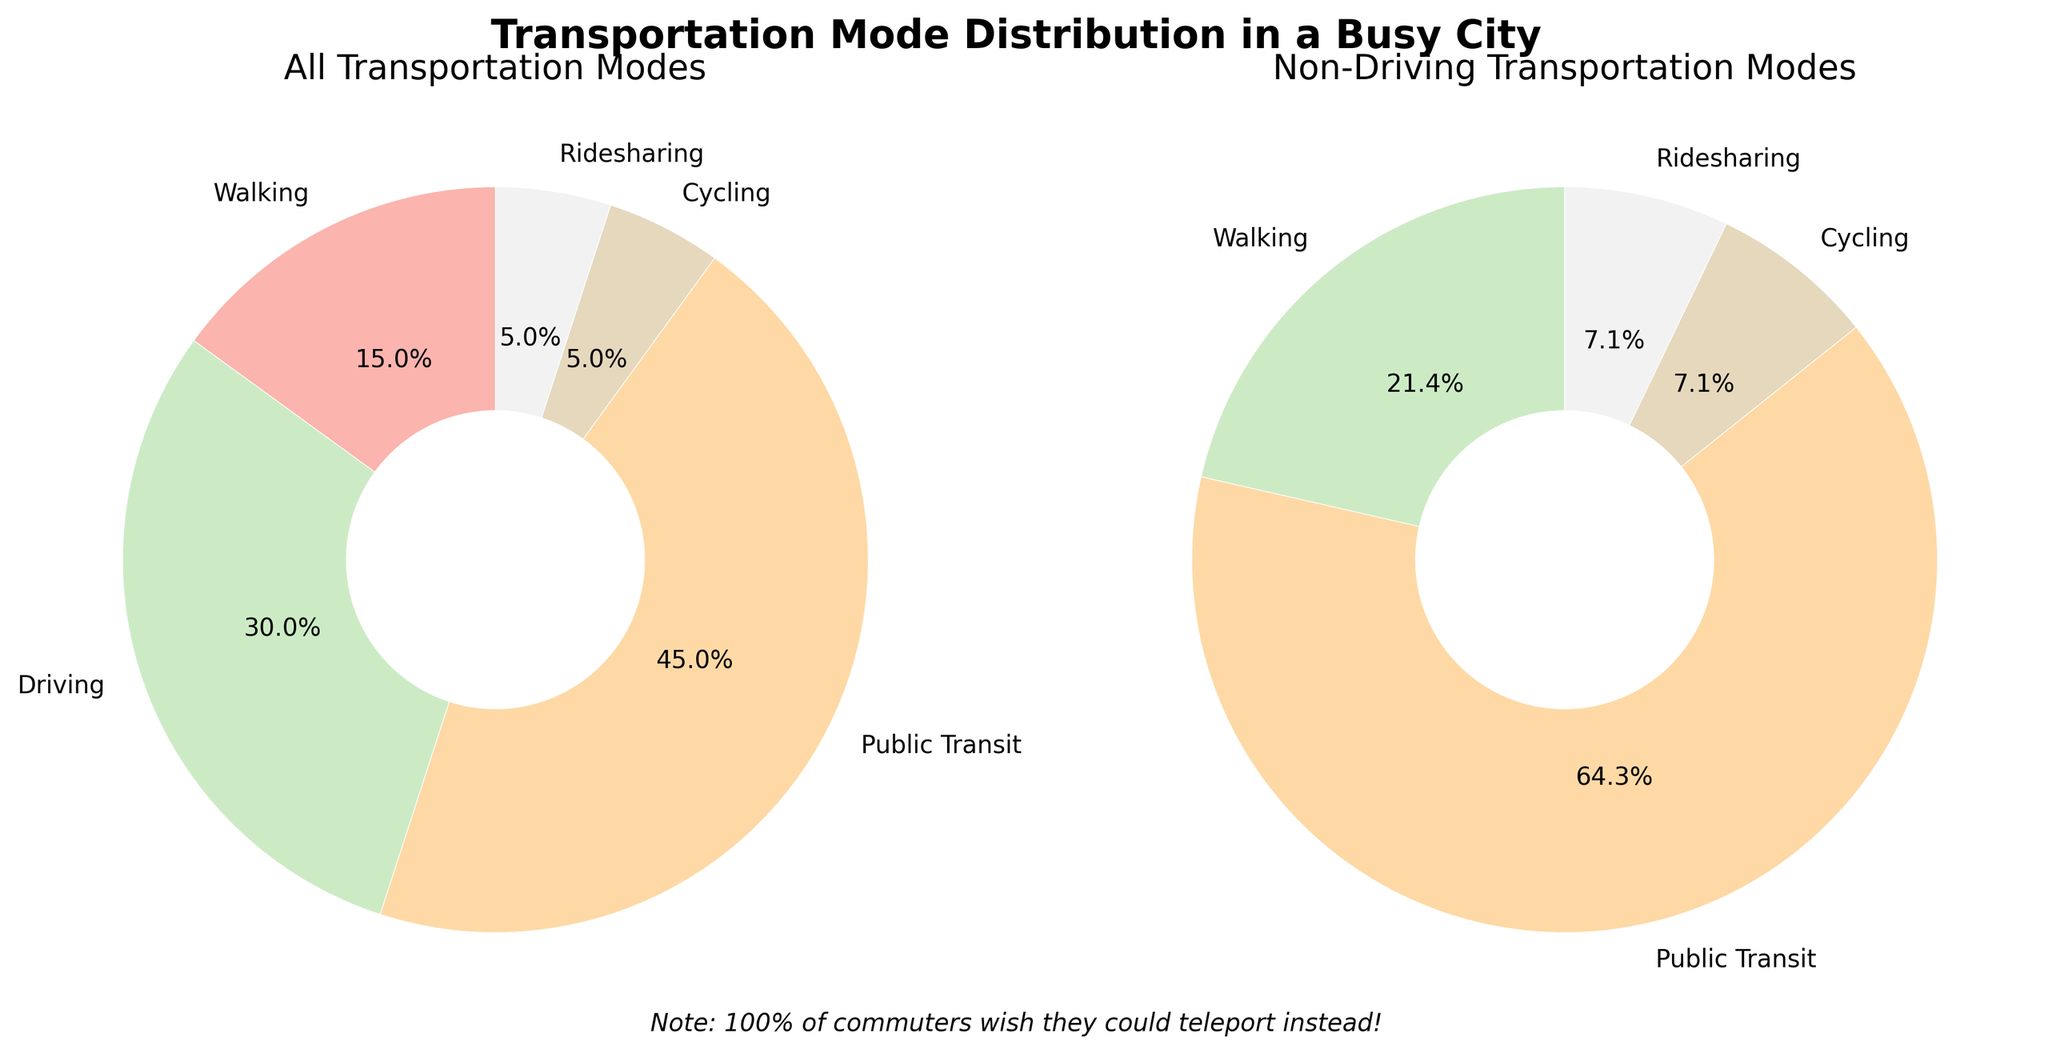What's the largest transportation mode by percentage in the first pie chart? Referring to the first pie chart, the segment with the label "Public Transit" has the largest percentage, which is 45%.
Answer: Public Transit What's the percentage of modes of transportation other than driving in the first chart? To find this, sum the percentages of all modes except "Driving": Walking (15%) + Public Transit (45%) + Cycling (5%) + Ridesharing (5%) = 70%.
Answer: 70% How does the presence of driving as a mode of transportation affect the distribution in the second pie chart? The second pie chart excludes the 30% driving segment, redistributing the remaining modes over 100%. This emphasizes the portions of Walking, Public Transit, Cycling, and Ridesharing over a different total.
Answer: Changes proportions significantly Which mode of transportation has the lowest percentage in both pie charts? In both the first and second pie charts, "Cycling" and "Ridesharing" share the lowest percentage with 5% each.
Answer: Cycling and Ridesharing What's the total percentage of non-driving modes in the second pie chart? The second pie chart already distributes non-driving modes to total 100%, showing 15% Walking, 45% Public Transit, 5% Cycling, and 5% Ridesharing. Summing these confirms they amount to 100%.
Answer: 100% How do the sizes of the Public Transit segments compare in the two pie charts? In the first pie chart, Public Transit is at 45%. In the second chart (excluding driving), Public Transit remains 45%, though it appears larger due to the removed driving segment.
Answer: Larger visually in the second chart What's the humorous note included in the figure? Referring to the text below the pie charts, it reads: "Note: 100% of commuters wish they could teleport instead!"
Answer: 100% of commuters wish teleport Which modes of transportation are tied in the second pie chart? In the second pie chart, "Cycling" and "Ridesharing" both have a 5% share.
Answer: Cycling and Ridesharing 